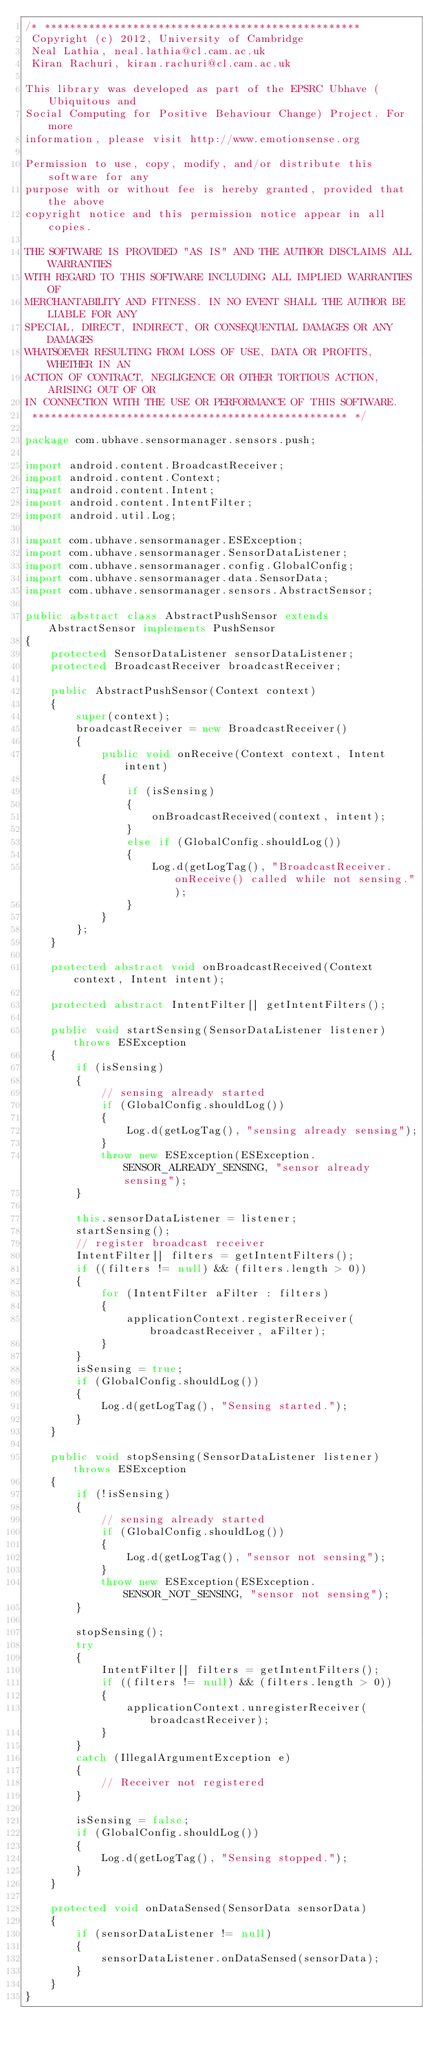<code> <loc_0><loc_0><loc_500><loc_500><_Java_>/* **************************************************
 Copyright (c) 2012, University of Cambridge
 Neal Lathia, neal.lathia@cl.cam.ac.uk
 Kiran Rachuri, kiran.rachuri@cl.cam.ac.uk

This library was developed as part of the EPSRC Ubhave (Ubiquitous and
Social Computing for Positive Behaviour Change) Project. For more
information, please visit http://www.emotionsense.org

Permission to use, copy, modify, and/or distribute this software for any
purpose with or without fee is hereby granted, provided that the above
copyright notice and this permission notice appear in all copies.

THE SOFTWARE IS PROVIDED "AS IS" AND THE AUTHOR DISCLAIMS ALL WARRANTIES
WITH REGARD TO THIS SOFTWARE INCLUDING ALL IMPLIED WARRANTIES OF
MERCHANTABILITY AND FITNESS. IN NO EVENT SHALL THE AUTHOR BE LIABLE FOR ANY
SPECIAL, DIRECT, INDIRECT, OR CONSEQUENTIAL DAMAGES OR ANY DAMAGES
WHATSOEVER RESULTING FROM LOSS OF USE, DATA OR PROFITS, WHETHER IN AN
ACTION OF CONTRACT, NEGLIGENCE OR OTHER TORTIOUS ACTION, ARISING OUT OF OR
IN CONNECTION WITH THE USE OR PERFORMANCE OF THIS SOFTWARE.
 ************************************************** */

package com.ubhave.sensormanager.sensors.push;

import android.content.BroadcastReceiver;
import android.content.Context;
import android.content.Intent;
import android.content.IntentFilter;
import android.util.Log;

import com.ubhave.sensormanager.ESException;
import com.ubhave.sensormanager.SensorDataListener;
import com.ubhave.sensormanager.config.GlobalConfig;
import com.ubhave.sensormanager.data.SensorData;
import com.ubhave.sensormanager.sensors.AbstractSensor;

public abstract class AbstractPushSensor extends AbstractSensor implements PushSensor
{
	protected SensorDataListener sensorDataListener;
	protected BroadcastReceiver broadcastReceiver;

	public AbstractPushSensor(Context context)
	{
		super(context);
		broadcastReceiver = new BroadcastReceiver()
		{
			public void onReceive(Context context, Intent intent)
			{
				if (isSensing)
				{
					onBroadcastReceived(context, intent);
				}
				else if (GlobalConfig.shouldLog())
				{
					Log.d(getLogTag(), "BroadcastReceiver.onReceive() called while not sensing.");
				}
			}
		};
	}
	
	protected abstract void onBroadcastReceived(Context context, Intent intent);

	protected abstract IntentFilter[] getIntentFilters();

	public void startSensing(SensorDataListener listener) throws ESException
	{
		if (isSensing)
		{
			// sensing already started
			if (GlobalConfig.shouldLog())
			{
				Log.d(getLogTag(), "sensing already sensing");
			}
			throw new ESException(ESException.SENSOR_ALREADY_SENSING, "sensor already sensing");
		}

		this.sensorDataListener = listener;
		startSensing();
		// register broadcast receiver
		IntentFilter[] filters = getIntentFilters();
		if ((filters != null) && (filters.length > 0))
		{
			for (IntentFilter aFilter : filters)
			{
				applicationContext.registerReceiver(broadcastReceiver, aFilter);
			}
		}
		isSensing = true;
		if (GlobalConfig.shouldLog())
		{
			Log.d(getLogTag(), "Sensing started.");
		}
	}

	public void stopSensing(SensorDataListener listener) throws ESException
	{
		if (!isSensing)
		{
			// sensing already started
			if (GlobalConfig.shouldLog())
			{
				Log.d(getLogTag(), "sensor not sensing");
			}
			throw new ESException(ESException.SENSOR_NOT_SENSING, "sensor not sensing");
		}

		stopSensing();
		try
		{
			IntentFilter[] filters = getIntentFilters();
			if ((filters != null) && (filters.length > 0))
			{
				applicationContext.unregisterReceiver(broadcastReceiver);
			}
		}
		catch (IllegalArgumentException e)
		{
			// Receiver not registered
		}
		
		isSensing = false;
		if (GlobalConfig.shouldLog())
		{
			Log.d(getLogTag(), "Sensing stopped.");
		}
	}

	protected void onDataSensed(SensorData sensorData)
	{
		if (sensorDataListener != null)
		{
			sensorDataListener.onDataSensed(sensorData);
		}
	}
}
</code> 